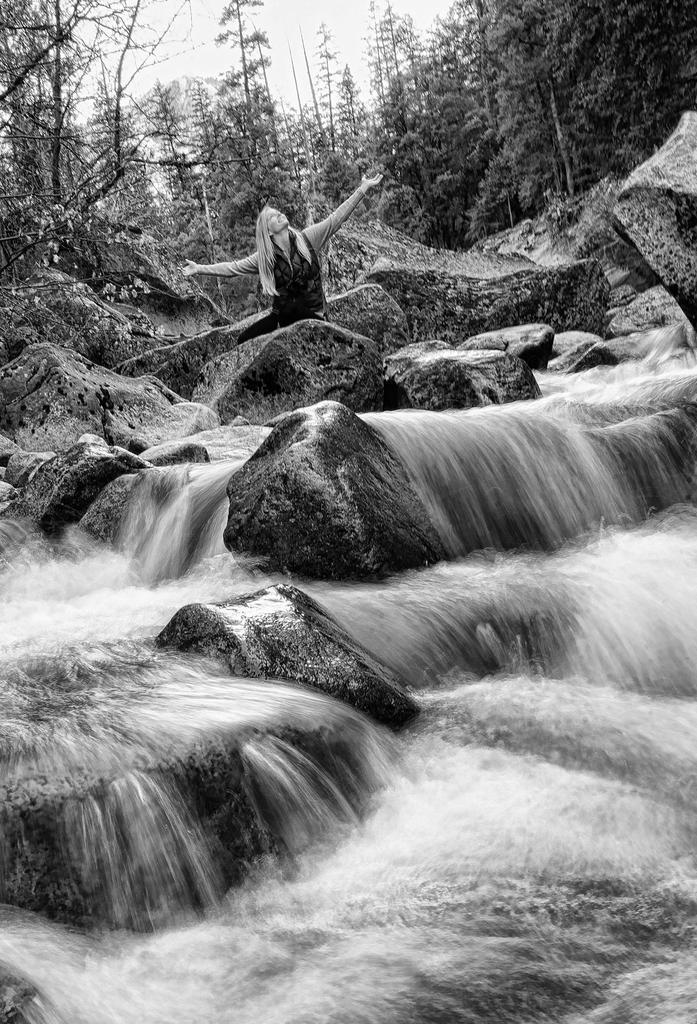What is the color scheme of the image? The image is black and white. Can you describe the main subject in the image? There is a person in the image. What type of natural elements can be seen in the image? There are rocks, water, and trees in the image. What can be seen in the background of the image? The sky is visible in the background of the image, along with trees. What type of shade does the person in the image prefer? There is no information about the person's shade preference in the image. What is the person in the image learning? There is no indication of the person learning anything in the image. 